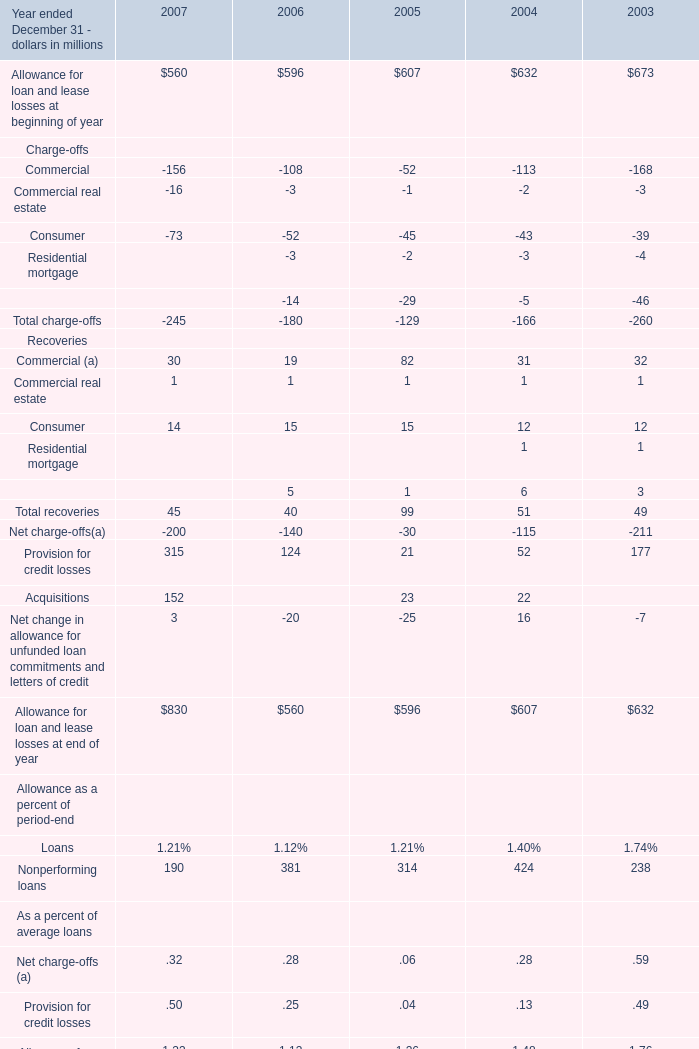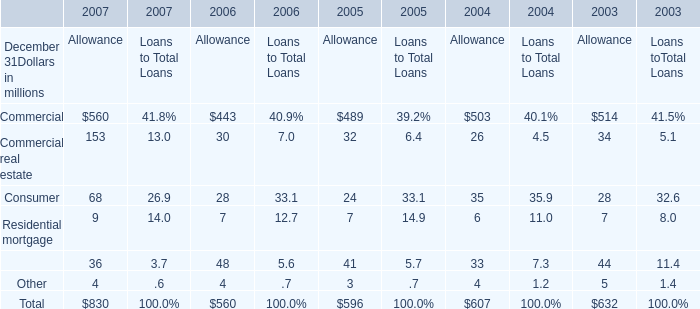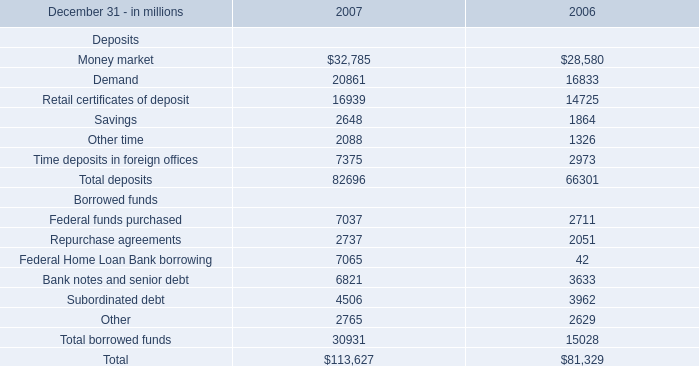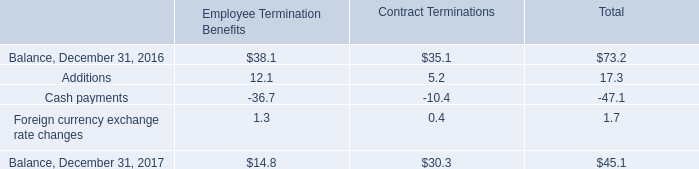what was the percentage change in the allowance for doubtful accounts between 2016 and 2017? 
Computations: ((60.2 - 51.6) / 51.6)
Answer: 0.16667. 